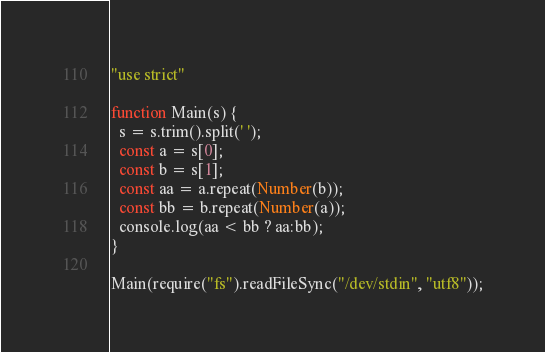<code> <loc_0><loc_0><loc_500><loc_500><_JavaScript_>"use strict"
 
function Main(s) {
  s = s.trim().split(' ');
  const a = s[0];
  const b = s[1];
  const aa = a.repeat(Number(b));
  const bb = b.repeat(Number(a));
  console.log(aa < bb ? aa:bb);
}

Main(require("fs").readFileSync("/dev/stdin", "utf8"));</code> 